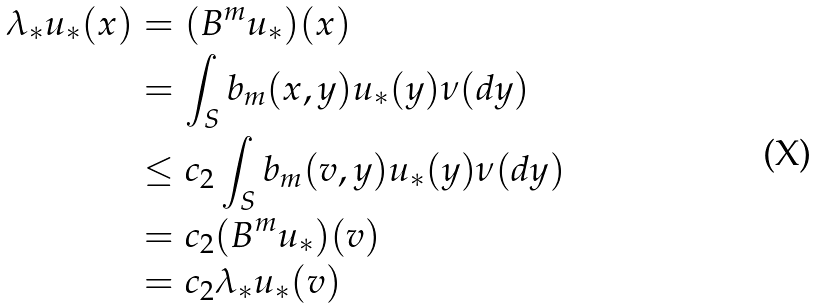<formula> <loc_0><loc_0><loc_500><loc_500>\lambda _ { * } u _ { * } ( x ) & = ( B ^ { m } u _ { * } ) ( x ) \\ & = \int _ { S } b _ { m } ( x , y ) u _ { * } ( y ) \nu ( d y ) \\ & \leq c _ { 2 } \int _ { S } b _ { m } ( v , y ) u _ { * } ( y ) \nu ( d y ) \\ & = c _ { 2 } ( B ^ { m } u _ { * } ) ( v ) \\ & = c _ { 2 } \lambda _ { * } u _ { * } ( v )</formula> 